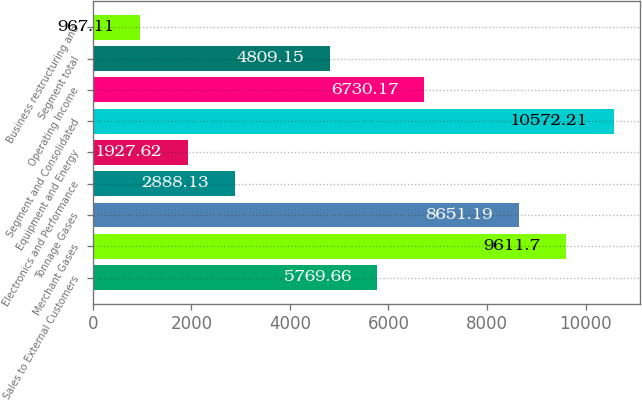Convert chart to OTSL. <chart><loc_0><loc_0><loc_500><loc_500><bar_chart><fcel>Sales to External Customers<fcel>Merchant Gases<fcel>Tonnage Gases<fcel>Electronics and Performance<fcel>Equipment and Energy<fcel>Segment and Consolidated<fcel>Operating Income<fcel>Segment total<fcel>Business restructuring and<nl><fcel>5769.66<fcel>9611.7<fcel>8651.19<fcel>2888.13<fcel>1927.62<fcel>10572.2<fcel>6730.17<fcel>4809.15<fcel>967.11<nl></chart> 